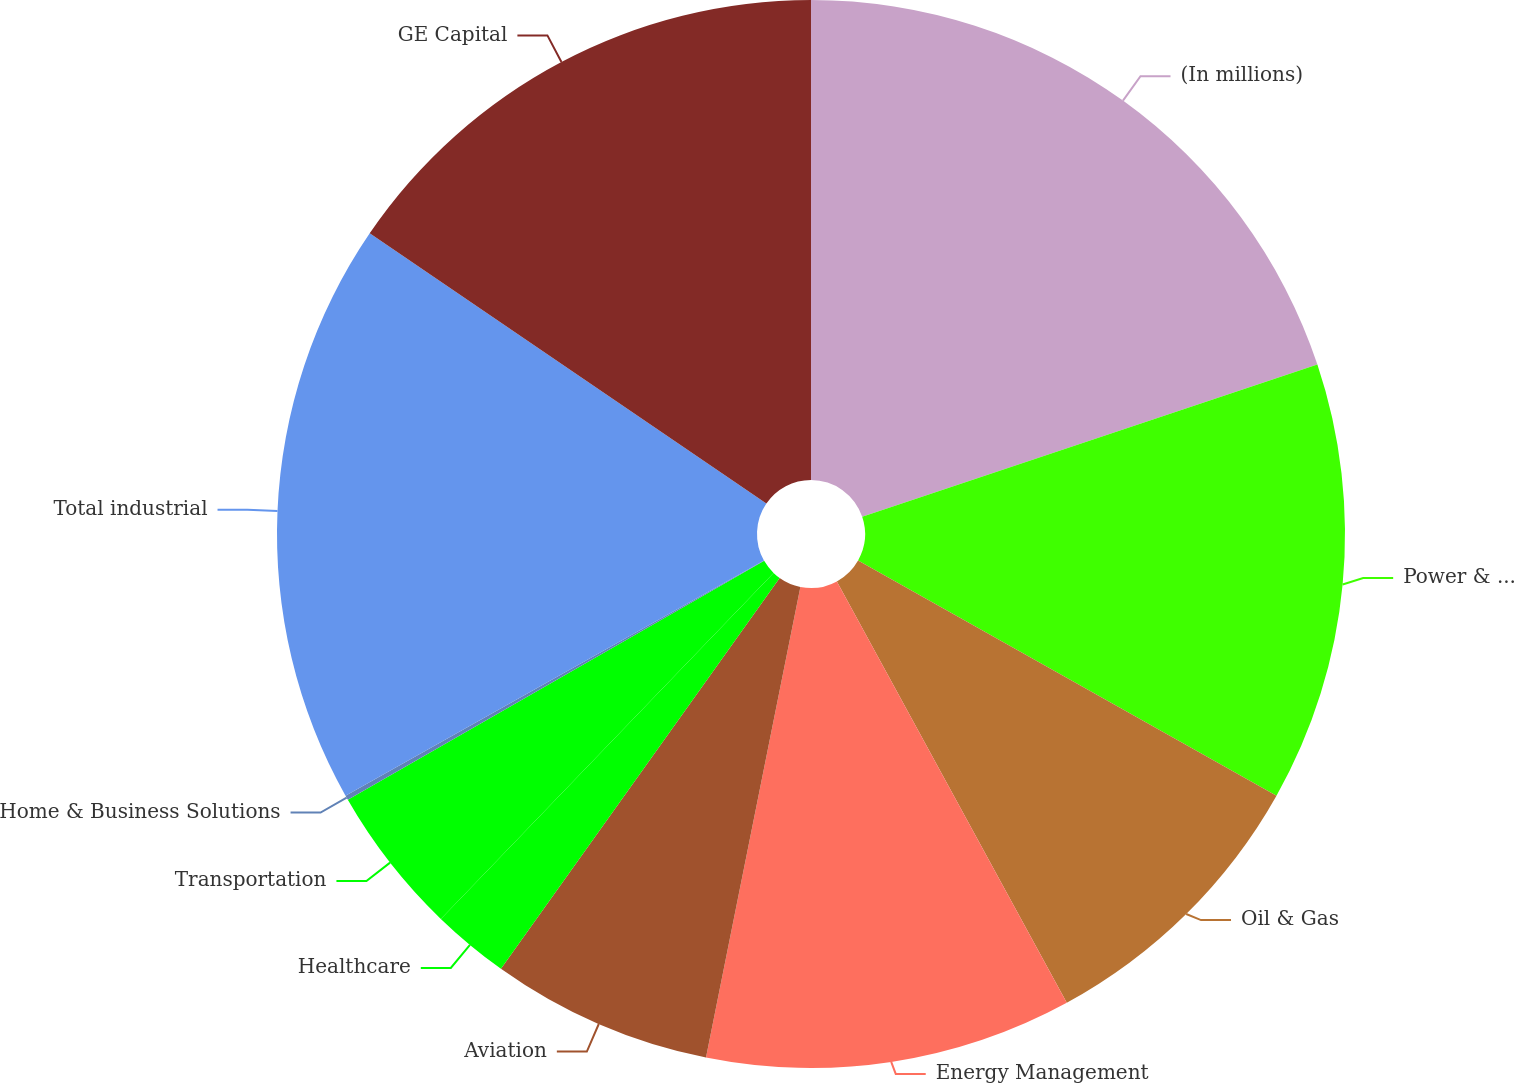Convert chart to OTSL. <chart><loc_0><loc_0><loc_500><loc_500><pie_chart><fcel>(In millions)<fcel>Power & Water<fcel>Oil & Gas<fcel>Energy Management<fcel>Aviation<fcel>Healthcare<fcel>Transportation<fcel>Home & Business Solutions<fcel>Total industrial<fcel>GE Capital<nl><fcel>19.86%<fcel>13.29%<fcel>8.9%<fcel>11.1%<fcel>6.71%<fcel>2.33%<fcel>4.52%<fcel>0.14%<fcel>17.67%<fcel>15.48%<nl></chart> 